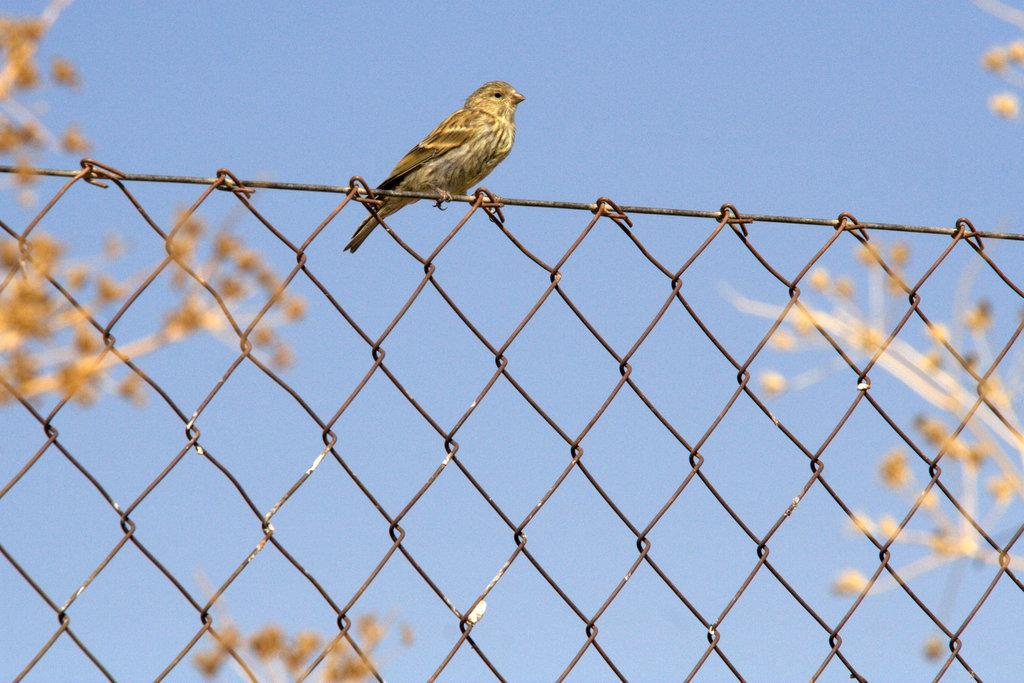What animal can be seen on the fence in the image? There is a bird on a fence in the image. What type of vegetation is present on the left side of the image? There are branches on a plant on the left side of the image. What type of vegetation is present on the right side of the image? There are branches on a plant on the right side of the image. What can be seen in the background of the image? The sky is visible in the background of the image. What type of oven is visible in the image? There is no oven present in the image. What might the bird feel if it experiences shame in the image? The image does not depict any emotions or feelings of the bird, so it is not possible to determine how the bird might feel if it experienced shame. 